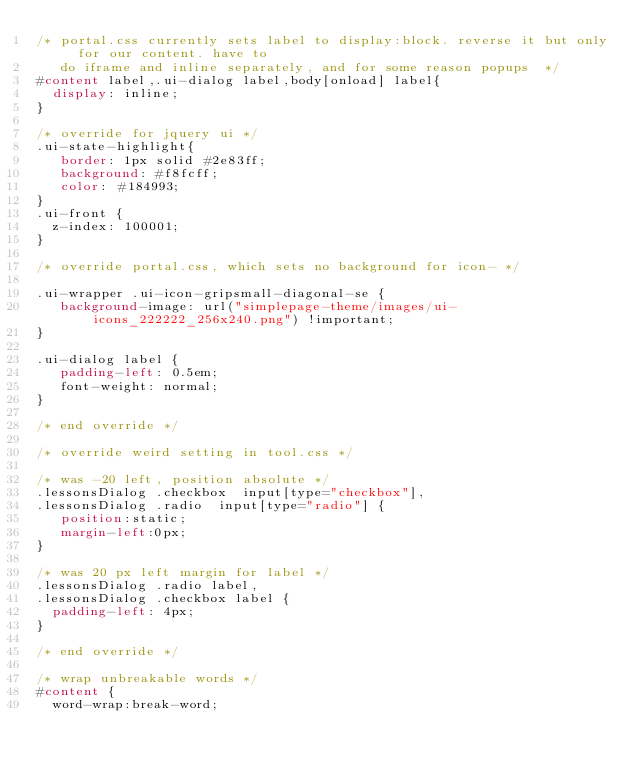Convert code to text. <code><loc_0><loc_0><loc_500><loc_500><_CSS_>/* portal.css currently sets label to display:block. reverse it but only for our content. have to
   do iframe and inline separately, and for some reason popups  */
#content label,.ui-dialog label,body[onload] label{
  display: inline;
}

/* override for jquery ui */
.ui-state-highlight{
   border: 1px solid #2e83ff;
   background: #f8fcff;
   color: #184993;
}
.ui-front {
	z-index: 100001;
}

/* override portal.css, which sets no background for icon- */

.ui-wrapper .ui-icon-gripsmall-diagonal-se {
   background-image: url("simplepage-theme/images/ui-icons_222222_256x240.png") !important;
}

.ui-dialog label {
   padding-left: 0.5em;
   font-weight: normal;
}

/* end override */

/* override weird setting in tool.css */

/* was -20 left, position absolute */
.lessonsDialog .checkbox  input[type="checkbox"],
.lessonsDialog .radio  input[type="radio"] {
   position:static;
   margin-left:0px;
}

/* was 20 px left margin for label */
.lessonsDialog .radio label,
.lessonsDialog .checkbox label {
  padding-left: 4px;
}

/* end override */

/* wrap unbreakable words */
#content {
  word-wrap:break-word;</code> 